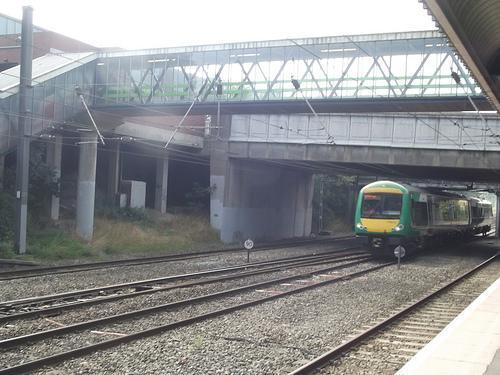How many trains are in the photo?
Give a very brief answer. 1. 